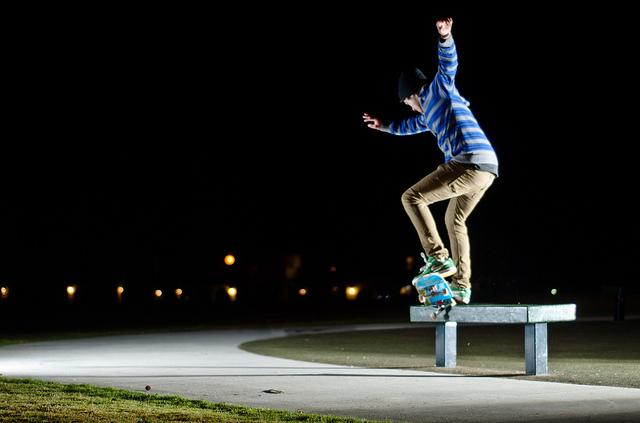Does this person have enough light to perform this sport?
Write a very short answer. Yes. Is this skateboarder grinding?
Write a very short answer. Yes. Is he wearing safety gear?
Write a very short answer. No. 